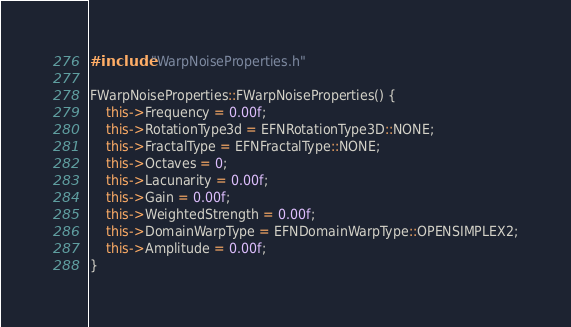<code> <loc_0><loc_0><loc_500><loc_500><_C++_>#include "WarpNoiseProperties.h"

FWarpNoiseProperties::FWarpNoiseProperties() {
    this->Frequency = 0.00f;
    this->RotationType3d = EFNRotationType3D::NONE;
    this->FractalType = EFNFractalType::NONE;
    this->Octaves = 0;
    this->Lacunarity = 0.00f;
    this->Gain = 0.00f;
    this->WeightedStrength = 0.00f;
    this->DomainWarpType = EFNDomainWarpType::OPENSIMPLEX2;
    this->Amplitude = 0.00f;
}

</code> 